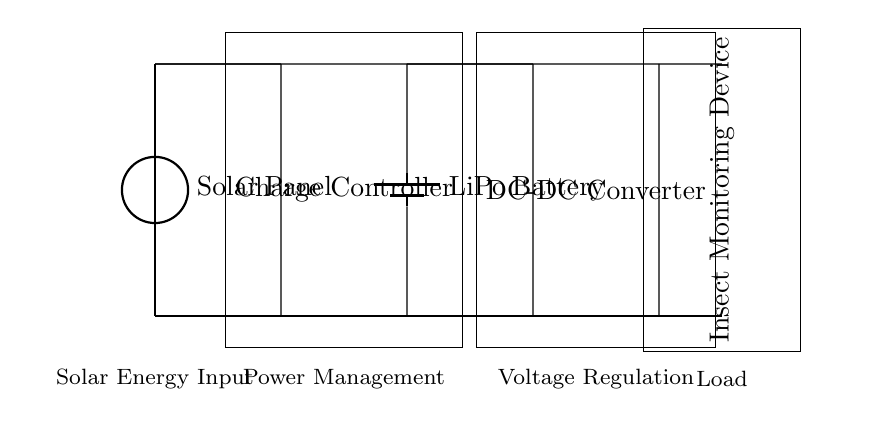What is the primary energy source for this circuit? The circuit is powered by a solar panel, indicated at the top left of the diagram, which converts solar energy into electrical energy.
Answer: Solar Panel What type of battery is used in this circuit? The diagram specifies a LiPo battery located in the middle right section, showing that it is a lithium polymer battery used for charging.
Answer: LiPo Battery What is the function of the charge controller in this circuit? The charge controller, represented by the rectangular box in the center, manages the energy flow from the solar panel to the battery to prevent overcharging and ensure safe operation.
Answer: Power Management How many main components are visible in the circuit? The circuit contains four main components: a solar panel, a charge controller, a battery, and a DC-DC converter. This total is counted visually by identifying each distinct component present.
Answer: Four What is the role of the DC-DC converter in this solar-powered circuit? The DC-DC converter, depicted on the right side, regulates the battery voltage down to the appropriate level required for the monitoring device, ensuring it operates properly with a consistent voltage supply.
Answer: Voltage Regulation What happens to the current flow after the charge controller? After the charge controller, the current flows into the LiPo battery for storage and then continues to the DC-DC converter, where it is converted before reaching the insect monitoring device.
Answer: Flows to Battery, then DC-DC Converter Which component directly powers the insect monitoring device? The insect monitoring device is powered directly by the output of the DC-DC converter, which adjusts the voltage for its operational needs.
Answer: DC-DC Converter 